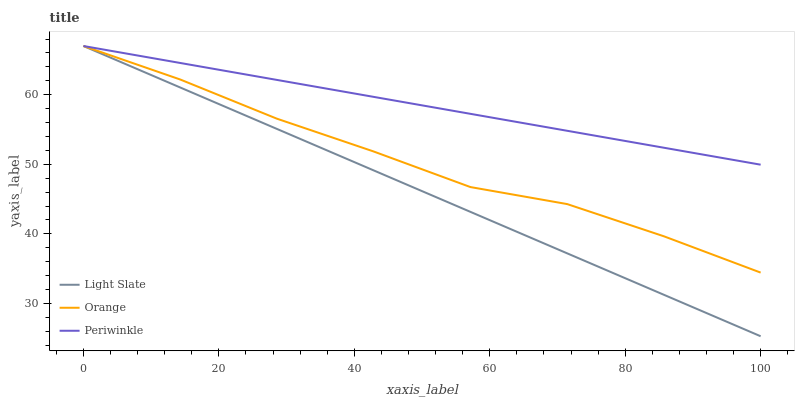Does Light Slate have the minimum area under the curve?
Answer yes or no. Yes. Does Periwinkle have the maximum area under the curve?
Answer yes or no. Yes. Does Orange have the minimum area under the curve?
Answer yes or no. No. Does Orange have the maximum area under the curve?
Answer yes or no. No. Is Light Slate the smoothest?
Answer yes or no. Yes. Is Orange the roughest?
Answer yes or no. Yes. Is Periwinkle the smoothest?
Answer yes or no. No. Is Periwinkle the roughest?
Answer yes or no. No. Does Light Slate have the lowest value?
Answer yes or no. Yes. Does Orange have the lowest value?
Answer yes or no. No. Does Periwinkle have the highest value?
Answer yes or no. Yes. Does Light Slate intersect Periwinkle?
Answer yes or no. Yes. Is Light Slate less than Periwinkle?
Answer yes or no. No. Is Light Slate greater than Periwinkle?
Answer yes or no. No. 